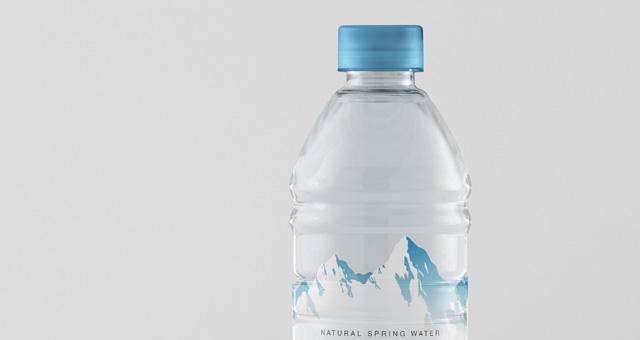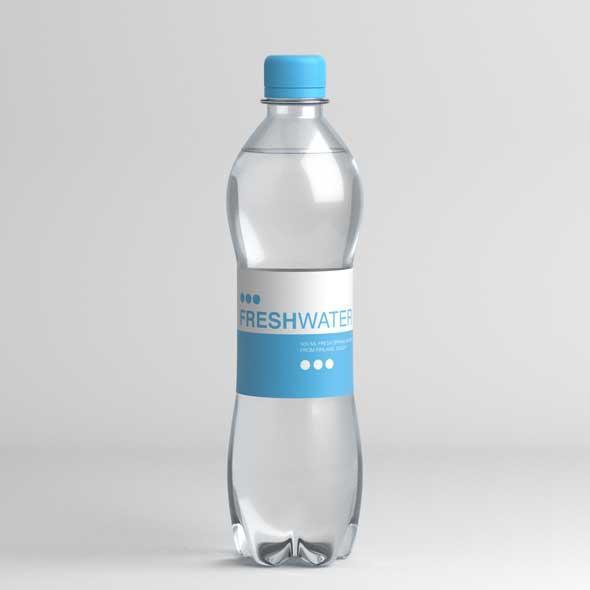The first image is the image on the left, the second image is the image on the right. Analyze the images presented: Is the assertion "The left image contains no more than one bottle." valid? Answer yes or no. Yes. The first image is the image on the left, the second image is the image on the right. Considering the images on both sides, is "Three bottles are grouped together in the image on the left." valid? Answer yes or no. No. 